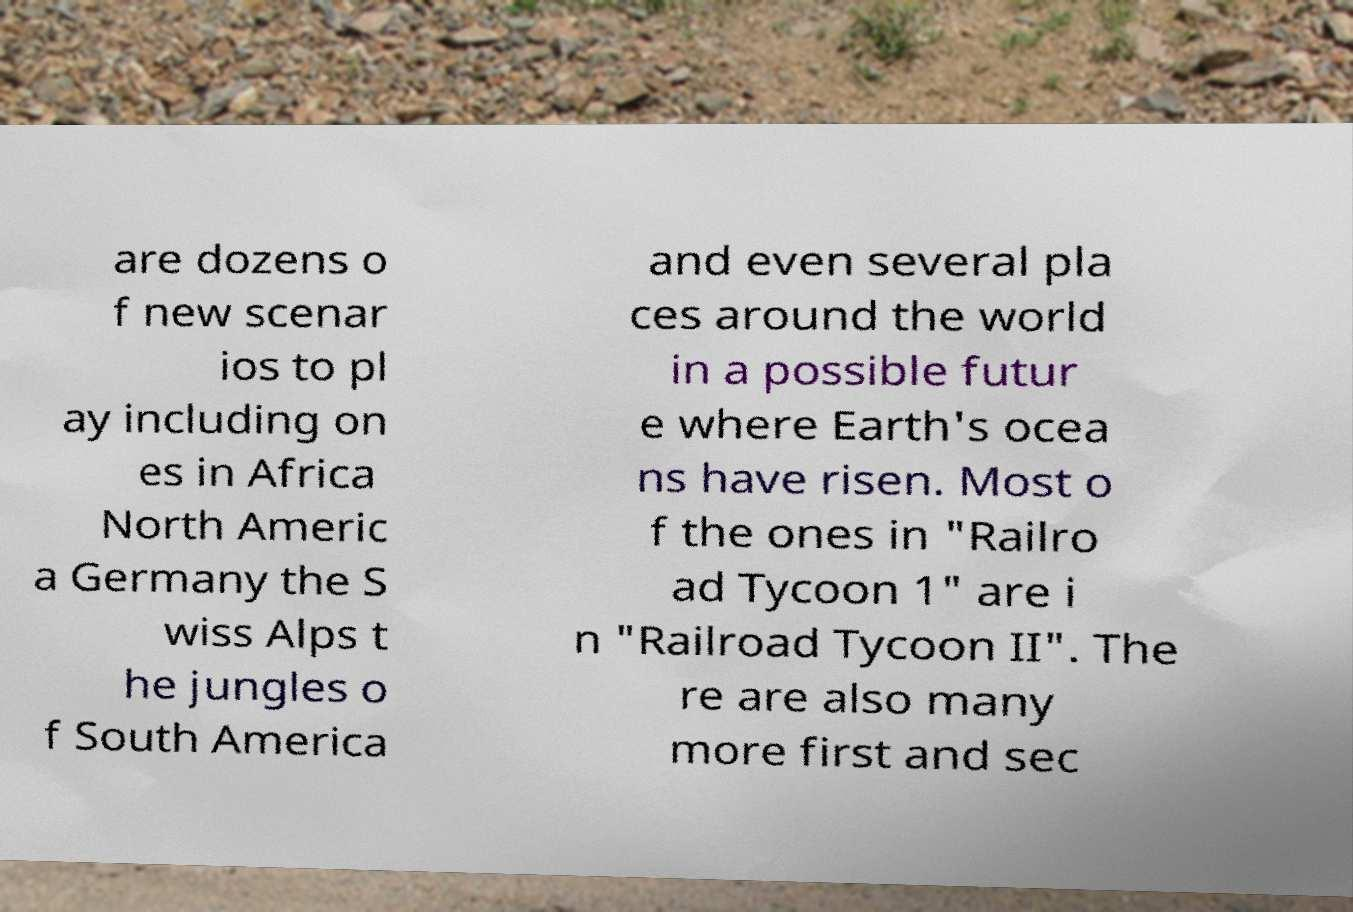There's text embedded in this image that I need extracted. Can you transcribe it verbatim? are dozens o f new scenar ios to pl ay including on es in Africa North Americ a Germany the S wiss Alps t he jungles o f South America and even several pla ces around the world in a possible futur e where Earth's ocea ns have risen. Most o f the ones in "Railro ad Tycoon 1" are i n "Railroad Tycoon II". The re are also many more first and sec 